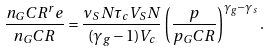Convert formula to latex. <formula><loc_0><loc_0><loc_500><loc_500>\frac { n _ { G } C R ^ { r } e } { n _ { G } C R } = \frac { \nu _ { S } N \tau _ { c } V _ { S } N } { ( \gamma _ { g } - 1 ) V _ { c } } \left ( \frac { p } { p _ { G } C R } \right ) ^ { \gamma _ { g } - \gamma _ { s } } .</formula> 